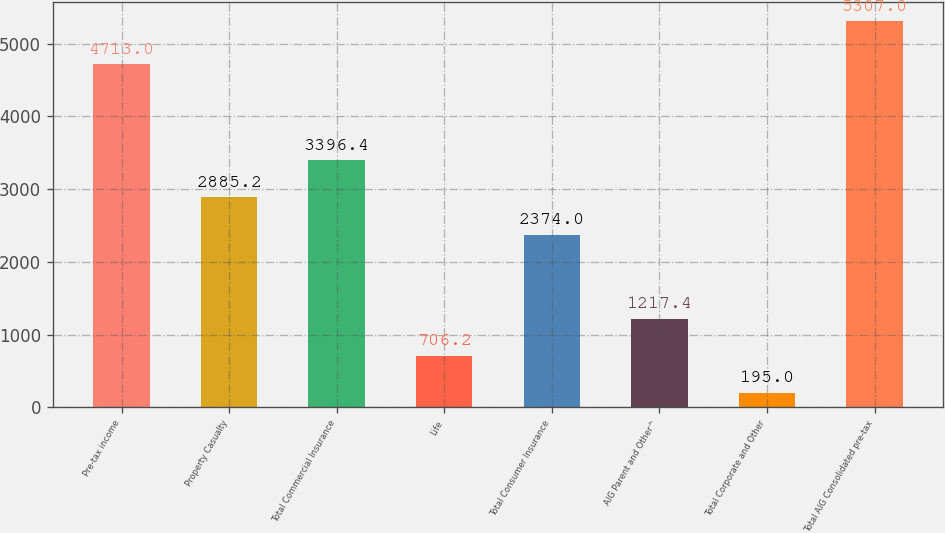Convert chart. <chart><loc_0><loc_0><loc_500><loc_500><bar_chart><fcel>Pre-tax income<fcel>Property Casualty<fcel>Total Commercial Insurance<fcel>Life<fcel>Total Consumer Insurance<fcel>AIG Parent and Other^<fcel>Total Corporate and Other<fcel>Total AIG Consolidated pre-tax<nl><fcel>4713<fcel>2885.2<fcel>3396.4<fcel>706.2<fcel>2374<fcel>1217.4<fcel>195<fcel>5307<nl></chart> 